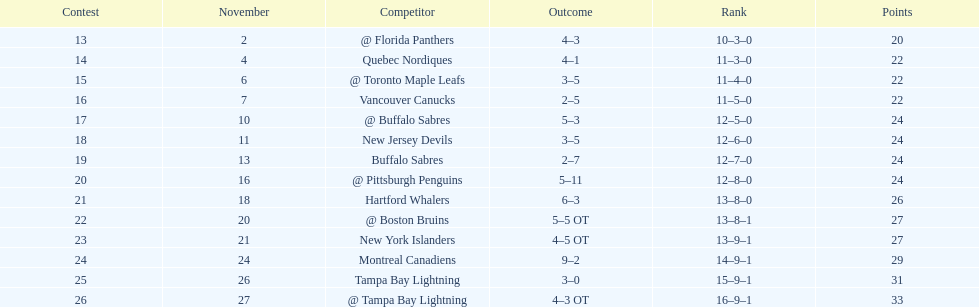The 1993-1994 flyers missed the playoffs again. how many consecutive seasons up until 93-94 did the flyers miss the playoffs? 5. 